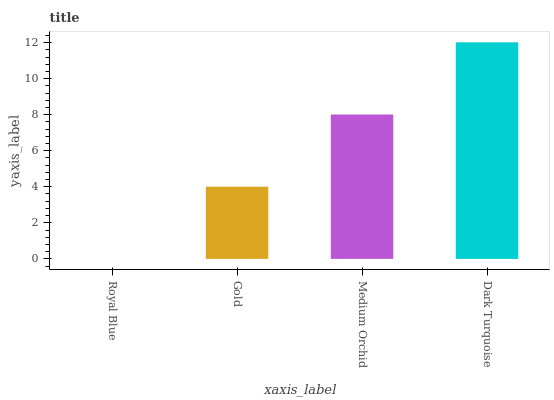Is Royal Blue the minimum?
Answer yes or no. Yes. Is Dark Turquoise the maximum?
Answer yes or no. Yes. Is Gold the minimum?
Answer yes or no. No. Is Gold the maximum?
Answer yes or no. No. Is Gold greater than Royal Blue?
Answer yes or no. Yes. Is Royal Blue less than Gold?
Answer yes or no. Yes. Is Royal Blue greater than Gold?
Answer yes or no. No. Is Gold less than Royal Blue?
Answer yes or no. No. Is Medium Orchid the high median?
Answer yes or no. Yes. Is Gold the low median?
Answer yes or no. Yes. Is Gold the high median?
Answer yes or no. No. Is Royal Blue the low median?
Answer yes or no. No. 